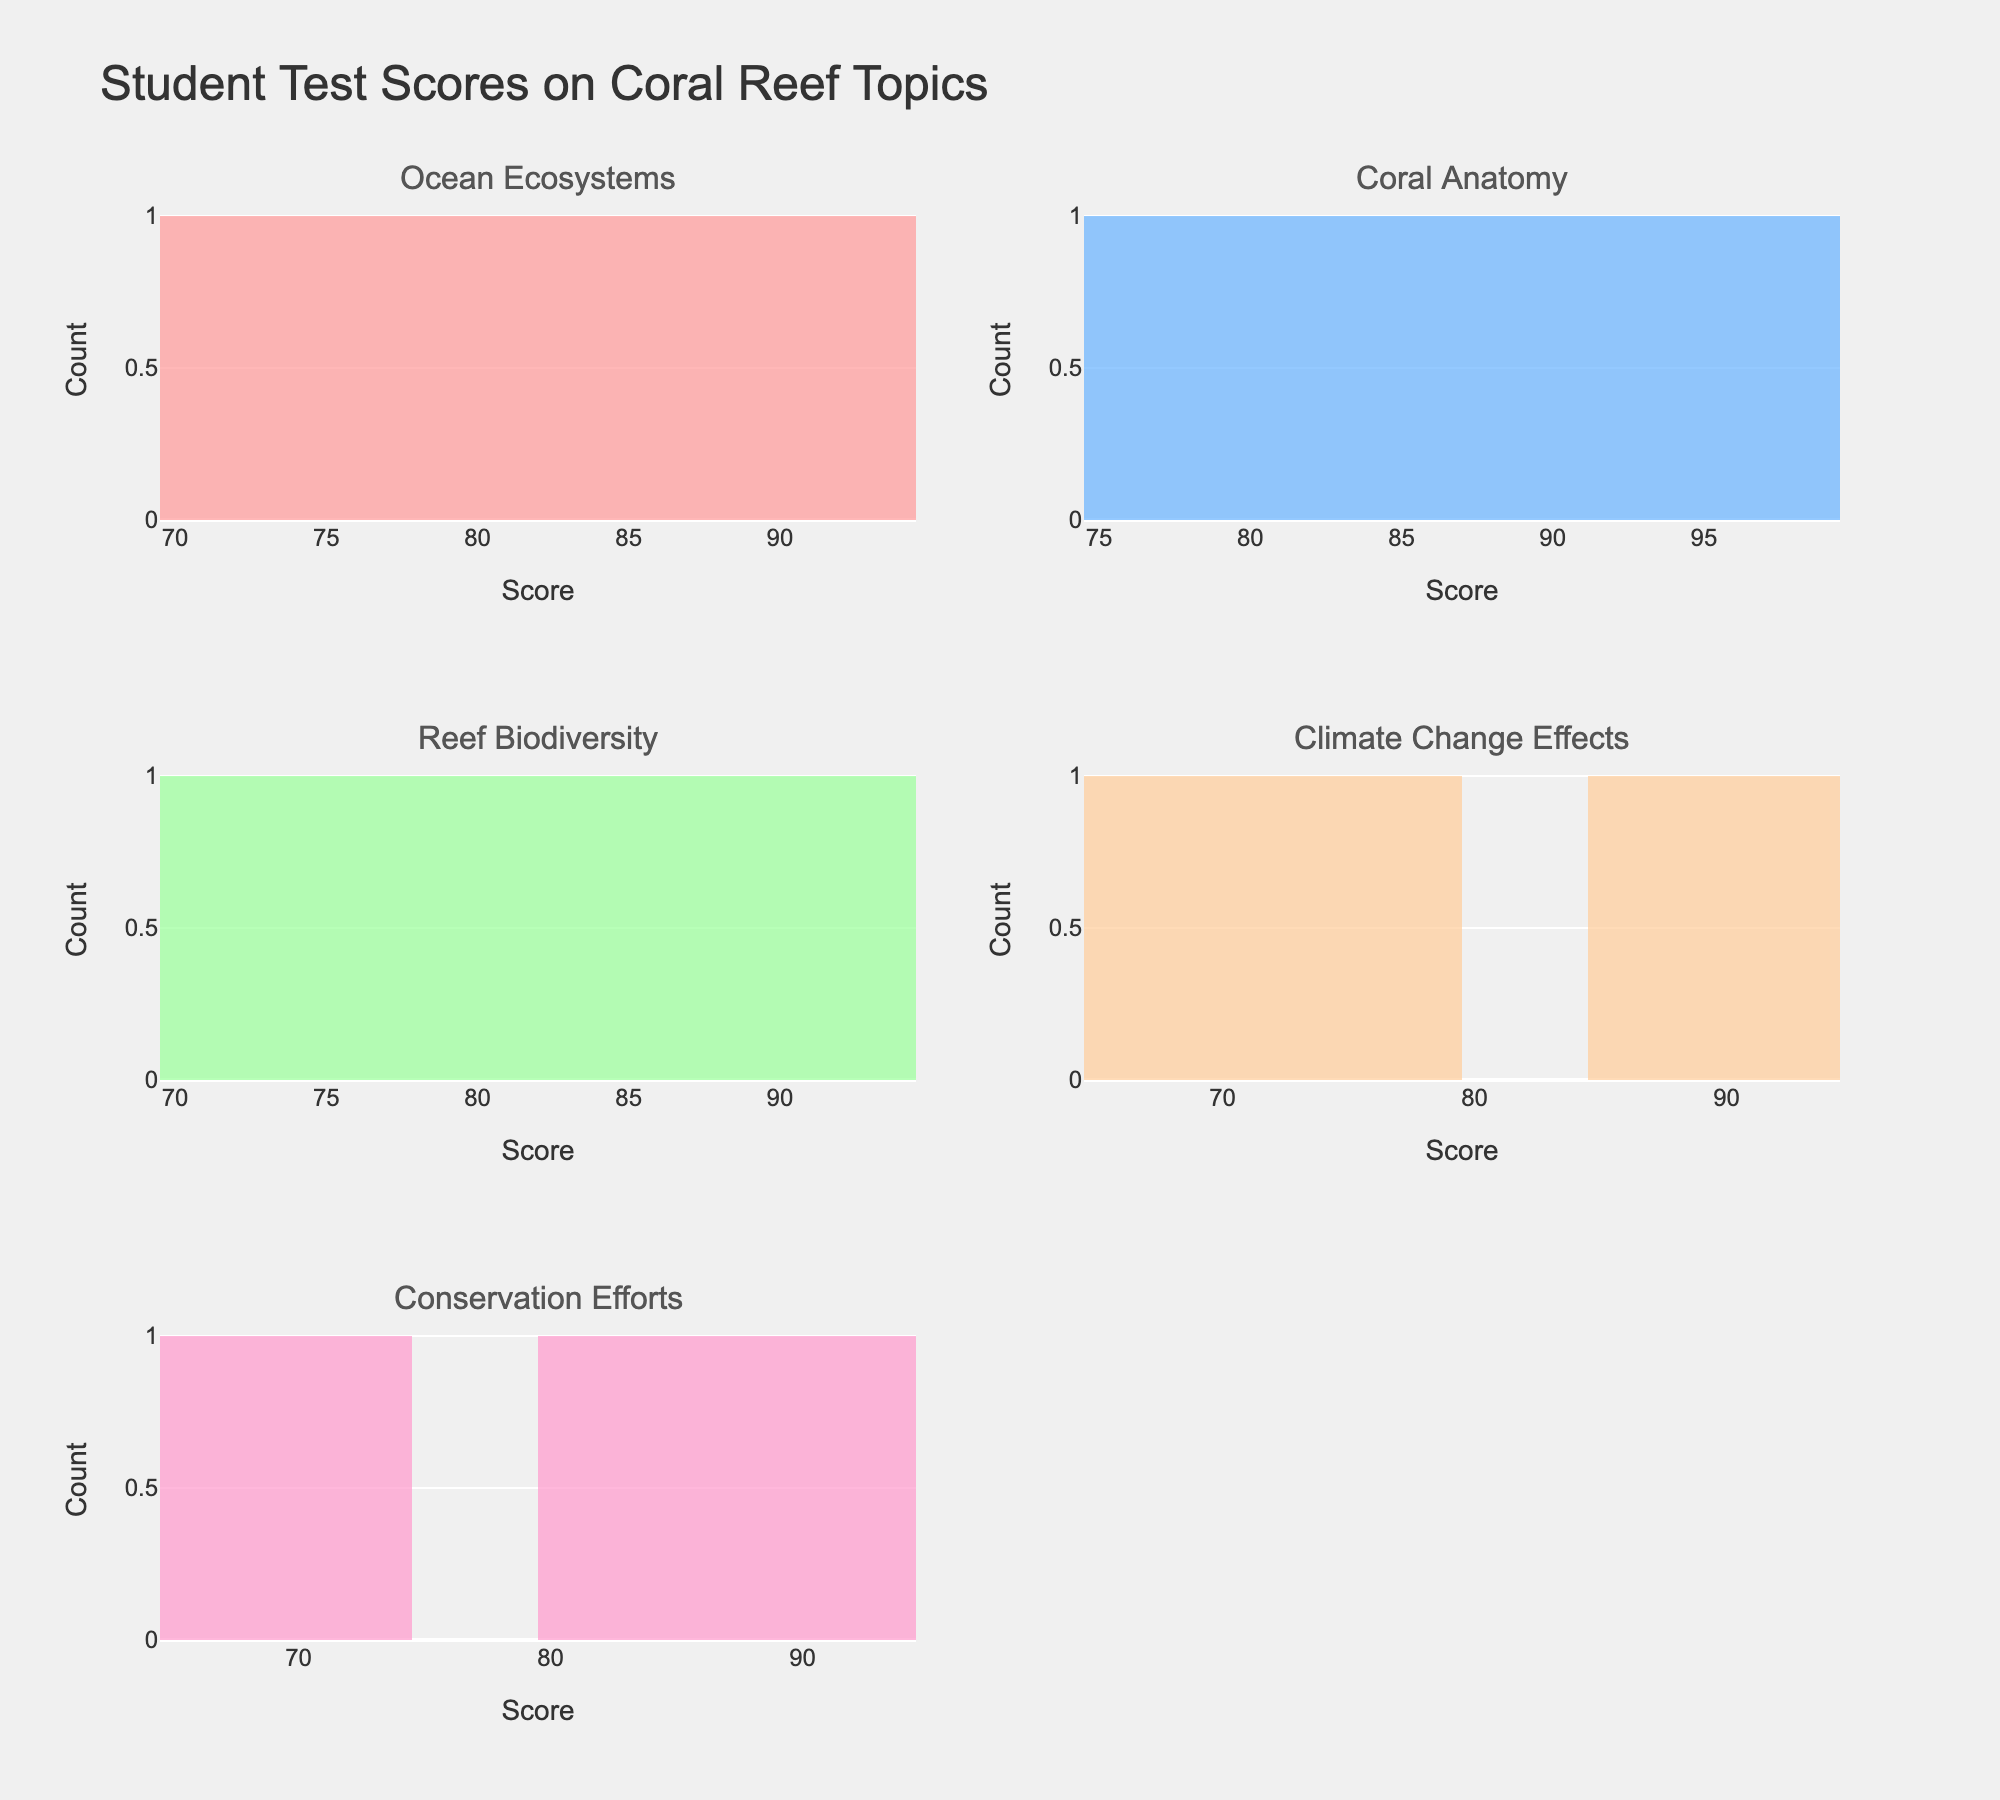What is the title of the figure? The title can be found at the top of the figure. It usually describes the main subject or insights portrayed in the figure.
Answer: Student Test Scores on Coral Reef Topics Which subject has the highest score in May? The histogram for each subject and month shows different scores. By looking at the subplot for "Conservation Efforts" in May, you can pick out the highest bar to find the highest score.
Answer: Conservation Efforts How many total data points are there in the subplot for Ocean Ecosystems? Counting the bars in the histogram for the Ocean Ecosystems subplot gives the number of data points. Each bar represents one data point.
Answer: 5 Compare the average scores between the Coral Anatomy and Reef Biodiversity topics. Which one is higher? To find the average, sum the scores for each subject and then divide by the number of data points. For Coral Anatomy: (70 + 75 + 82 + 88 + 92) / 5 = 81.4. For Reef Biodiversity: (68 + 74 + 80 + 86 + 91) / 5 = 79.8. Compare the two averages.
Answer: Coral Anatomy What range of scores appears most frequently for the Climate Change Effects topic? Look for the highest bar in the Climate Change Effects histogram and identify the score range it represents.
Answer: 83-89 Which subject has the most spread-out scores, and how can you tell? Spread is the range between the lowest and highest scores in a histogram. The wider the spread, the more variation in scores. Compare the range of scores for each subject.
Answer: Conservation Efforts Which Coral Reef topic had the least variation in student scores? The least variation means the scores are close to each other, which results in a narrower spread in the histogram. Compare the spreads of each subject to identify the least variation.
Answer: Coral Anatomy Is there a visible trend in scores as the school year progresses? Describe it. Look at the scores month by month and see if there is an increase, decrease, or no change. By examining these patterns, you may spot an overall trend.
Answer: Scores generally increase What is the highest score recorded across all subjects? Identify the tallest bar in the histograms for each subject, and from these, find the highest score overall.
Answer: 96 Which month had the highest concentration of perfect scores (if any)? Perfect scores (if any) would be 100. Check the histograms for each month and subject and see if any have bars at the score of 100.
Answer: None 